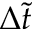<formula> <loc_0><loc_0><loc_500><loc_500>\Delta \tilde { t }</formula> 